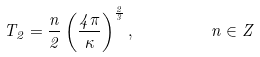<formula> <loc_0><loc_0><loc_500><loc_500>T _ { 2 } = \frac { n } { 2 } \left ( \frac { 4 \pi } { \kappa } \right ) ^ { \frac { 2 } { 3 } } , \quad \, \quad n \in Z</formula> 